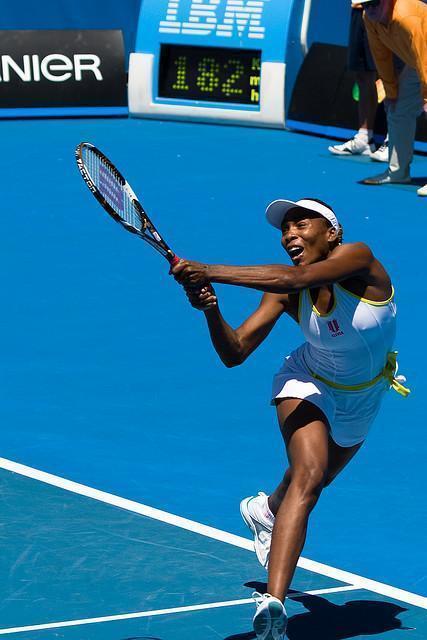What is her sister's name?
Select the accurate response from the four choices given to answer the question.
Options: Naomi, serena, anna, venus. Serena. 